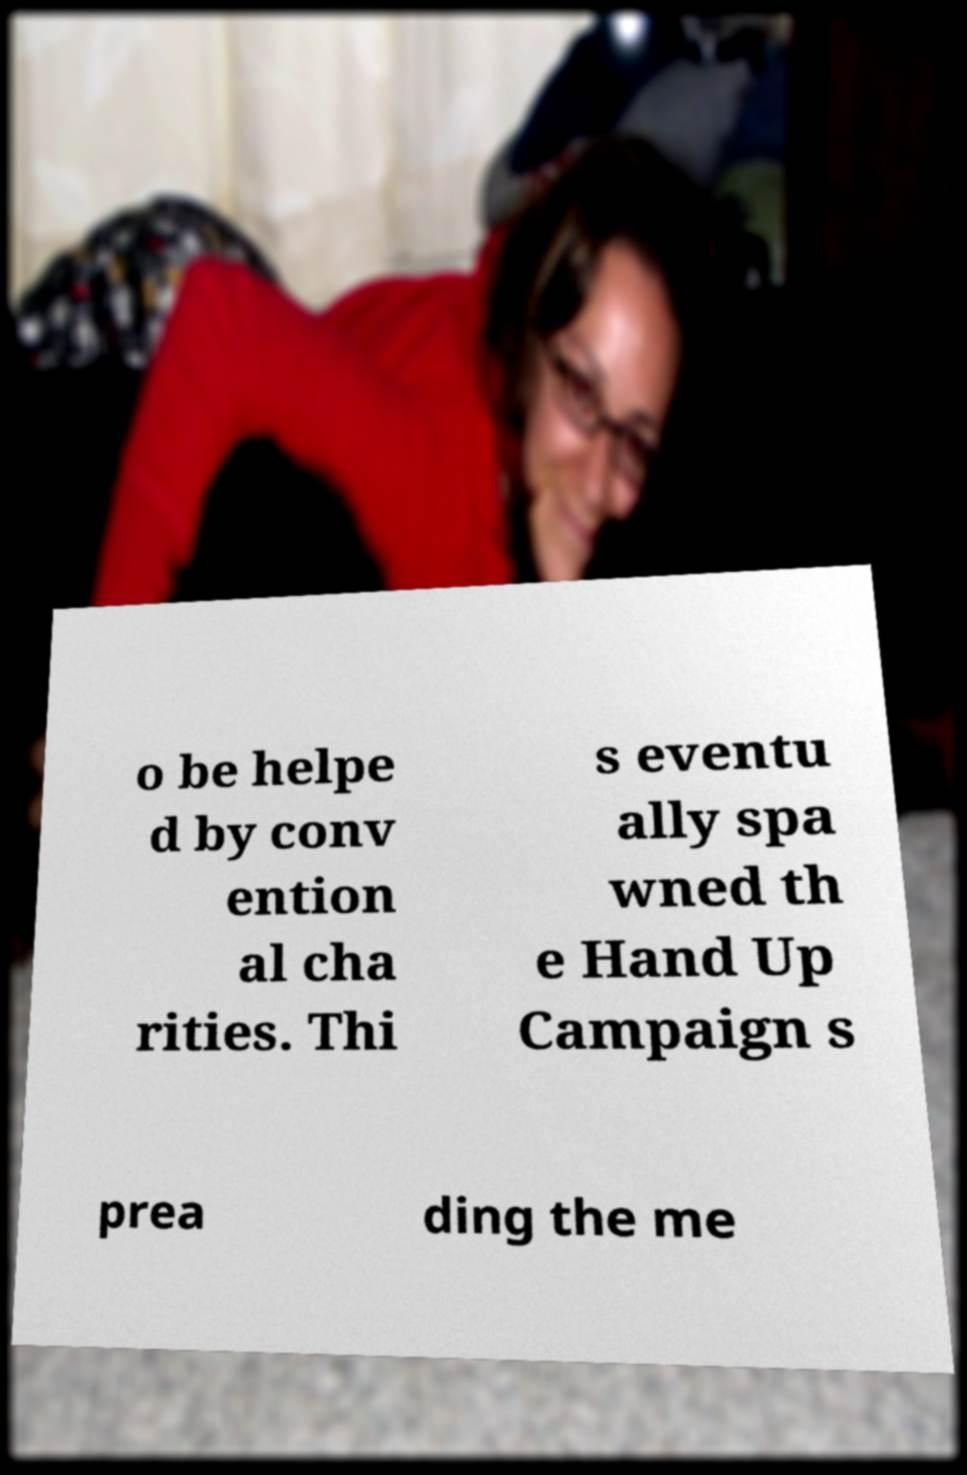Could you assist in decoding the text presented in this image and type it out clearly? o be helpe d by conv ention al cha rities. Thi s eventu ally spa wned th e Hand Up Campaign s prea ding the me 